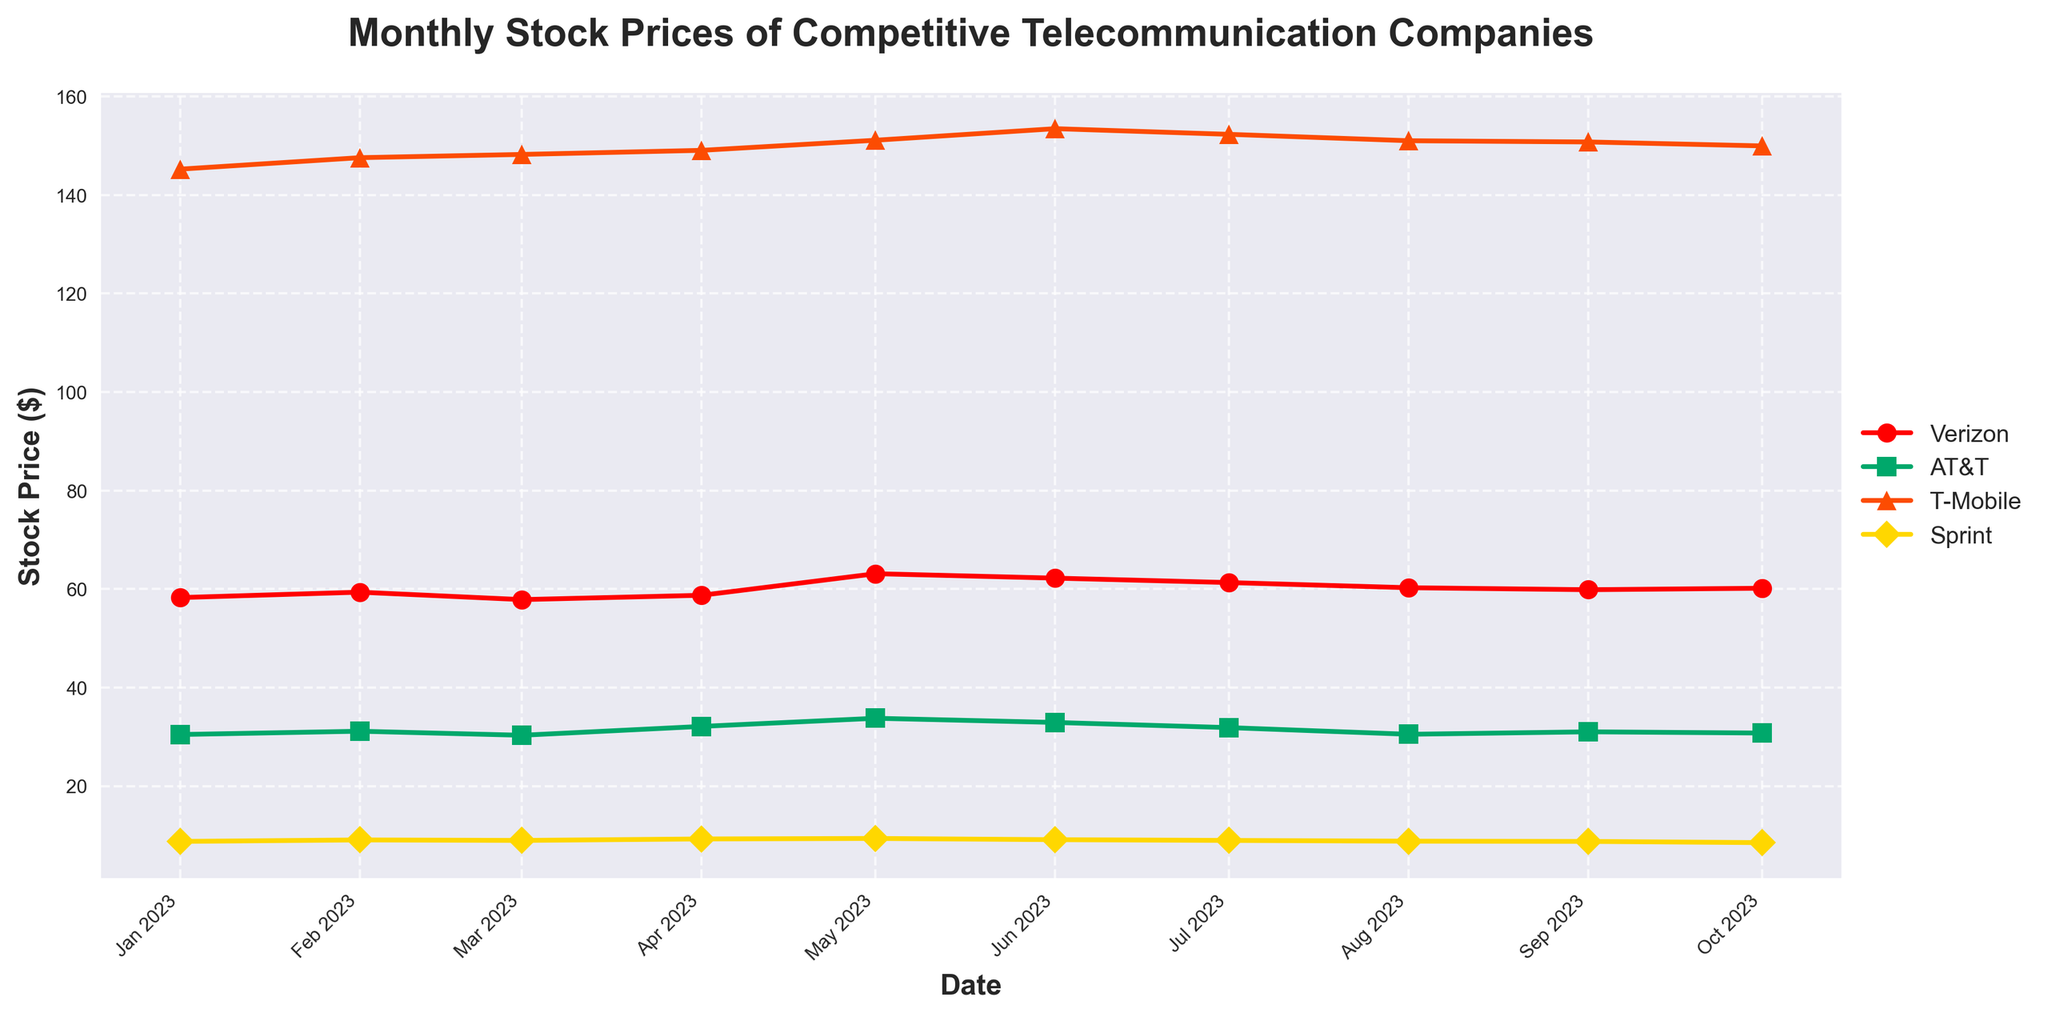Which telecommunication company had the highest stock price in October 2023? Looking at the figure, find the stock price for each company in October 2023 and identify the highest one among them.
Answer: T-Mobile What is the main trend observed for Verizon's stock price over the given period? By observing the plotted data points for Verizon, analyze the overall direction of the stock price from January to October 2023.
Answer: Mixed trend with fluctuations How does AT&T's stock price in January 2023 compare to its stock price in May 2023? Compare the stock prices of AT&T in January 2023 (30.45) and May 2023 (33.75) to determine if it increased or decreased.
Answer: Increased Over which months did Sprint experience a stock price increase? Examine Sprint's stock prices over the months and identify the ones where there is an upward movement from the previous month.
Answer: February, April, May Which company showed the least fluctuation in stock prices over the given period? Measure the range of stock prices (difference between highest and lowest) for each company and identify the one with the smallest range.
Answer: Sprint What is the average stock price of Verizon from January to October 2023? Add up all the monthly stock prices of Verizon and divide by the number of months (10).
Answer: 59.601 Which months did T-Mobile experience its highest and lowest stock prices? Identify the maximum and minimum stock prices for T-Mobile and check the corresponding months.
Answer: Highest: June 2023, Lowest: January 2023 By how much did Verizon's stock price change between its highest and lowest points in the given period? Find the highest and lowest stock prices of Verizon during the period and calculate the difference between them.
Answer: 5.26 Compare the stock price trends of Verizon and AT&T between May and August 2023. Analyze the stock price data points of Verizon and AT&T from May to August 2023 to determine the individual trends.
Answer: Verizon: Decline, AT&T: Decline 